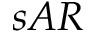<formula> <loc_0><loc_0><loc_500><loc_500>s A R</formula> 